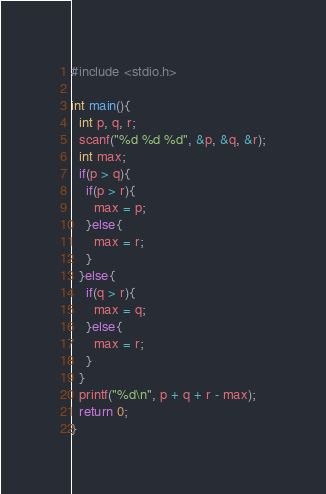<code> <loc_0><loc_0><loc_500><loc_500><_C_>#include <stdio.h>

int main(){
  int p, q, r;
  scanf("%d %d %d", &p, &q, &r);
  int max;
  if(p > q){
    if(p > r){
      max = p;
    }else{
      max = r;
    }
  }else{
    if(q > r){
      max = q;
    }else{
      max = r;
    }
  }
  printf("%d\n", p + q + r - max);
  return 0;
}
</code> 